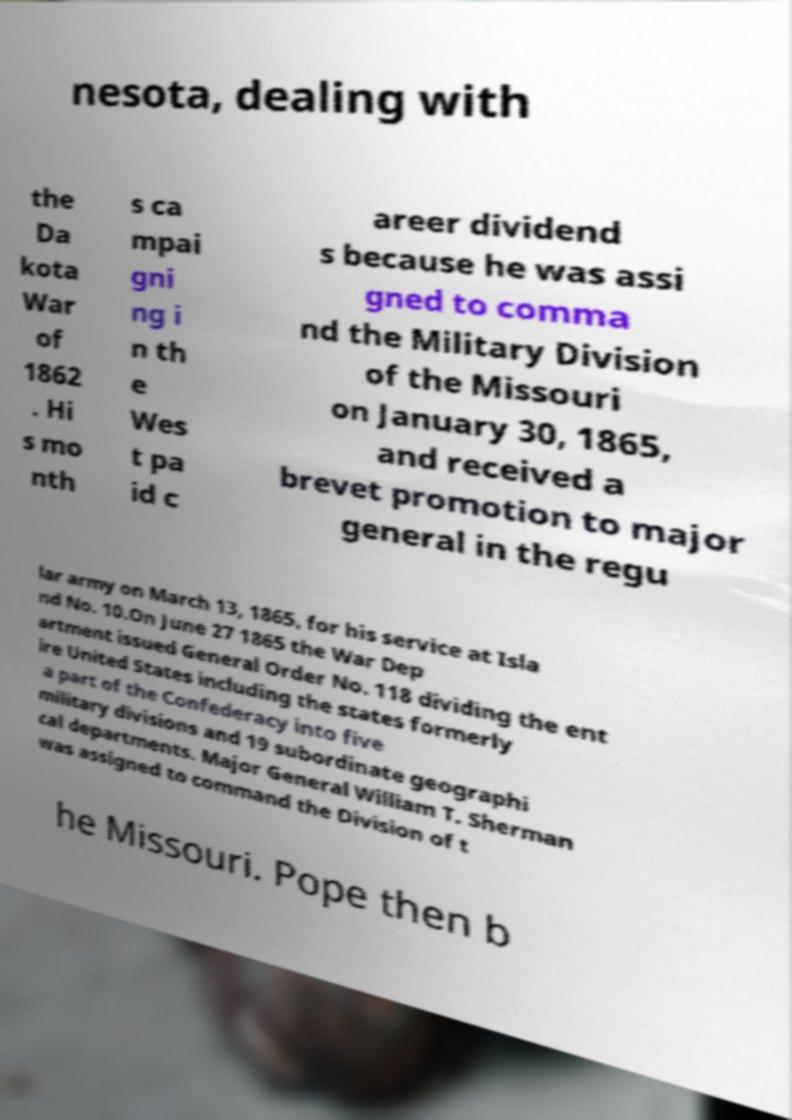Could you assist in decoding the text presented in this image and type it out clearly? nesota, dealing with the Da kota War of 1862 . Hi s mo nth s ca mpai gni ng i n th e Wes t pa id c areer dividend s because he was assi gned to comma nd the Military Division of the Missouri on January 30, 1865, and received a brevet promotion to major general in the regu lar army on March 13, 1865, for his service at Isla nd No. 10.On June 27 1865 the War Dep artment issued General Order No. 118 dividing the ent ire United States including the states formerly a part of the Confederacy into five military divisions and 19 subordinate geographi cal departments. Major General William T. Sherman was assigned to command the Division of t he Missouri. Pope then b 